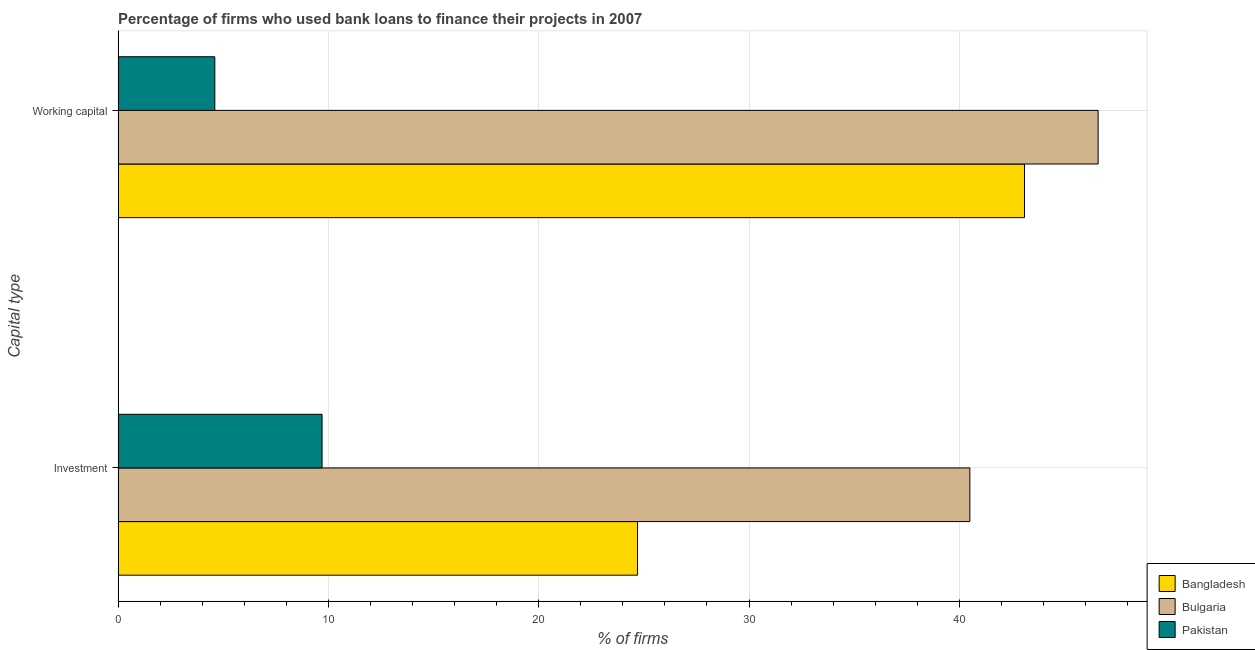Are the number of bars per tick equal to the number of legend labels?
Provide a succinct answer. Yes. Are the number of bars on each tick of the Y-axis equal?
Offer a terse response. Yes. What is the label of the 2nd group of bars from the top?
Offer a very short reply. Investment. What is the percentage of firms using banks to finance working capital in Bulgaria?
Give a very brief answer. 46.6. Across all countries, what is the maximum percentage of firms using banks to finance investment?
Offer a very short reply. 40.5. In which country was the percentage of firms using banks to finance working capital maximum?
Give a very brief answer. Bulgaria. In which country was the percentage of firms using banks to finance working capital minimum?
Make the answer very short. Pakistan. What is the total percentage of firms using banks to finance investment in the graph?
Provide a succinct answer. 74.9. What is the difference between the percentage of firms using banks to finance working capital in Bangladesh and that in Pakistan?
Your answer should be compact. 38.5. What is the difference between the percentage of firms using banks to finance investment in Pakistan and the percentage of firms using banks to finance working capital in Bangladesh?
Provide a succinct answer. -33.4. What is the average percentage of firms using banks to finance working capital per country?
Your answer should be compact. 31.43. What is the difference between the percentage of firms using banks to finance working capital and percentage of firms using banks to finance investment in Bulgaria?
Provide a short and direct response. 6.1. In how many countries, is the percentage of firms using banks to finance working capital greater than 42 %?
Your answer should be very brief. 2. What is the ratio of the percentage of firms using banks to finance working capital in Bulgaria to that in Pakistan?
Offer a very short reply. 10.13. Is the percentage of firms using banks to finance working capital in Bulgaria less than that in Bangladesh?
Your answer should be very brief. No. In how many countries, is the percentage of firms using banks to finance working capital greater than the average percentage of firms using banks to finance working capital taken over all countries?
Make the answer very short. 2. Are all the bars in the graph horizontal?
Offer a terse response. Yes. What is the difference between two consecutive major ticks on the X-axis?
Offer a terse response. 10. Are the values on the major ticks of X-axis written in scientific E-notation?
Your response must be concise. No. Does the graph contain any zero values?
Provide a short and direct response. No. How many legend labels are there?
Offer a very short reply. 3. What is the title of the graph?
Give a very brief answer. Percentage of firms who used bank loans to finance their projects in 2007. Does "East Asia (all income levels)" appear as one of the legend labels in the graph?
Provide a short and direct response. No. What is the label or title of the X-axis?
Make the answer very short. % of firms. What is the label or title of the Y-axis?
Your answer should be very brief. Capital type. What is the % of firms of Bangladesh in Investment?
Provide a short and direct response. 24.7. What is the % of firms of Bulgaria in Investment?
Make the answer very short. 40.5. What is the % of firms of Pakistan in Investment?
Offer a terse response. 9.7. What is the % of firms of Bangladesh in Working capital?
Your response must be concise. 43.1. What is the % of firms in Bulgaria in Working capital?
Make the answer very short. 46.6. What is the % of firms of Pakistan in Working capital?
Provide a succinct answer. 4.6. Across all Capital type, what is the maximum % of firms in Bangladesh?
Give a very brief answer. 43.1. Across all Capital type, what is the maximum % of firms in Bulgaria?
Your answer should be compact. 46.6. Across all Capital type, what is the minimum % of firms of Bangladesh?
Make the answer very short. 24.7. Across all Capital type, what is the minimum % of firms in Bulgaria?
Your answer should be very brief. 40.5. Across all Capital type, what is the minimum % of firms in Pakistan?
Your answer should be compact. 4.6. What is the total % of firms in Bangladesh in the graph?
Your answer should be very brief. 67.8. What is the total % of firms of Bulgaria in the graph?
Your answer should be very brief. 87.1. What is the total % of firms in Pakistan in the graph?
Your answer should be very brief. 14.3. What is the difference between the % of firms in Bangladesh in Investment and that in Working capital?
Offer a very short reply. -18.4. What is the difference between the % of firms of Bulgaria in Investment and that in Working capital?
Give a very brief answer. -6.1. What is the difference between the % of firms of Pakistan in Investment and that in Working capital?
Give a very brief answer. 5.1. What is the difference between the % of firms of Bangladesh in Investment and the % of firms of Bulgaria in Working capital?
Provide a succinct answer. -21.9. What is the difference between the % of firms in Bangladesh in Investment and the % of firms in Pakistan in Working capital?
Provide a short and direct response. 20.1. What is the difference between the % of firms of Bulgaria in Investment and the % of firms of Pakistan in Working capital?
Your answer should be very brief. 35.9. What is the average % of firms of Bangladesh per Capital type?
Provide a short and direct response. 33.9. What is the average % of firms of Bulgaria per Capital type?
Your answer should be very brief. 43.55. What is the average % of firms in Pakistan per Capital type?
Offer a very short reply. 7.15. What is the difference between the % of firms of Bangladesh and % of firms of Bulgaria in Investment?
Your answer should be compact. -15.8. What is the difference between the % of firms in Bulgaria and % of firms in Pakistan in Investment?
Offer a terse response. 30.8. What is the difference between the % of firms in Bangladesh and % of firms in Pakistan in Working capital?
Ensure brevity in your answer.  38.5. What is the ratio of the % of firms of Bangladesh in Investment to that in Working capital?
Offer a very short reply. 0.57. What is the ratio of the % of firms in Bulgaria in Investment to that in Working capital?
Your answer should be very brief. 0.87. What is the ratio of the % of firms of Pakistan in Investment to that in Working capital?
Give a very brief answer. 2.11. What is the difference between the highest and the lowest % of firms of Bangladesh?
Your response must be concise. 18.4. What is the difference between the highest and the lowest % of firms of Pakistan?
Keep it short and to the point. 5.1. 